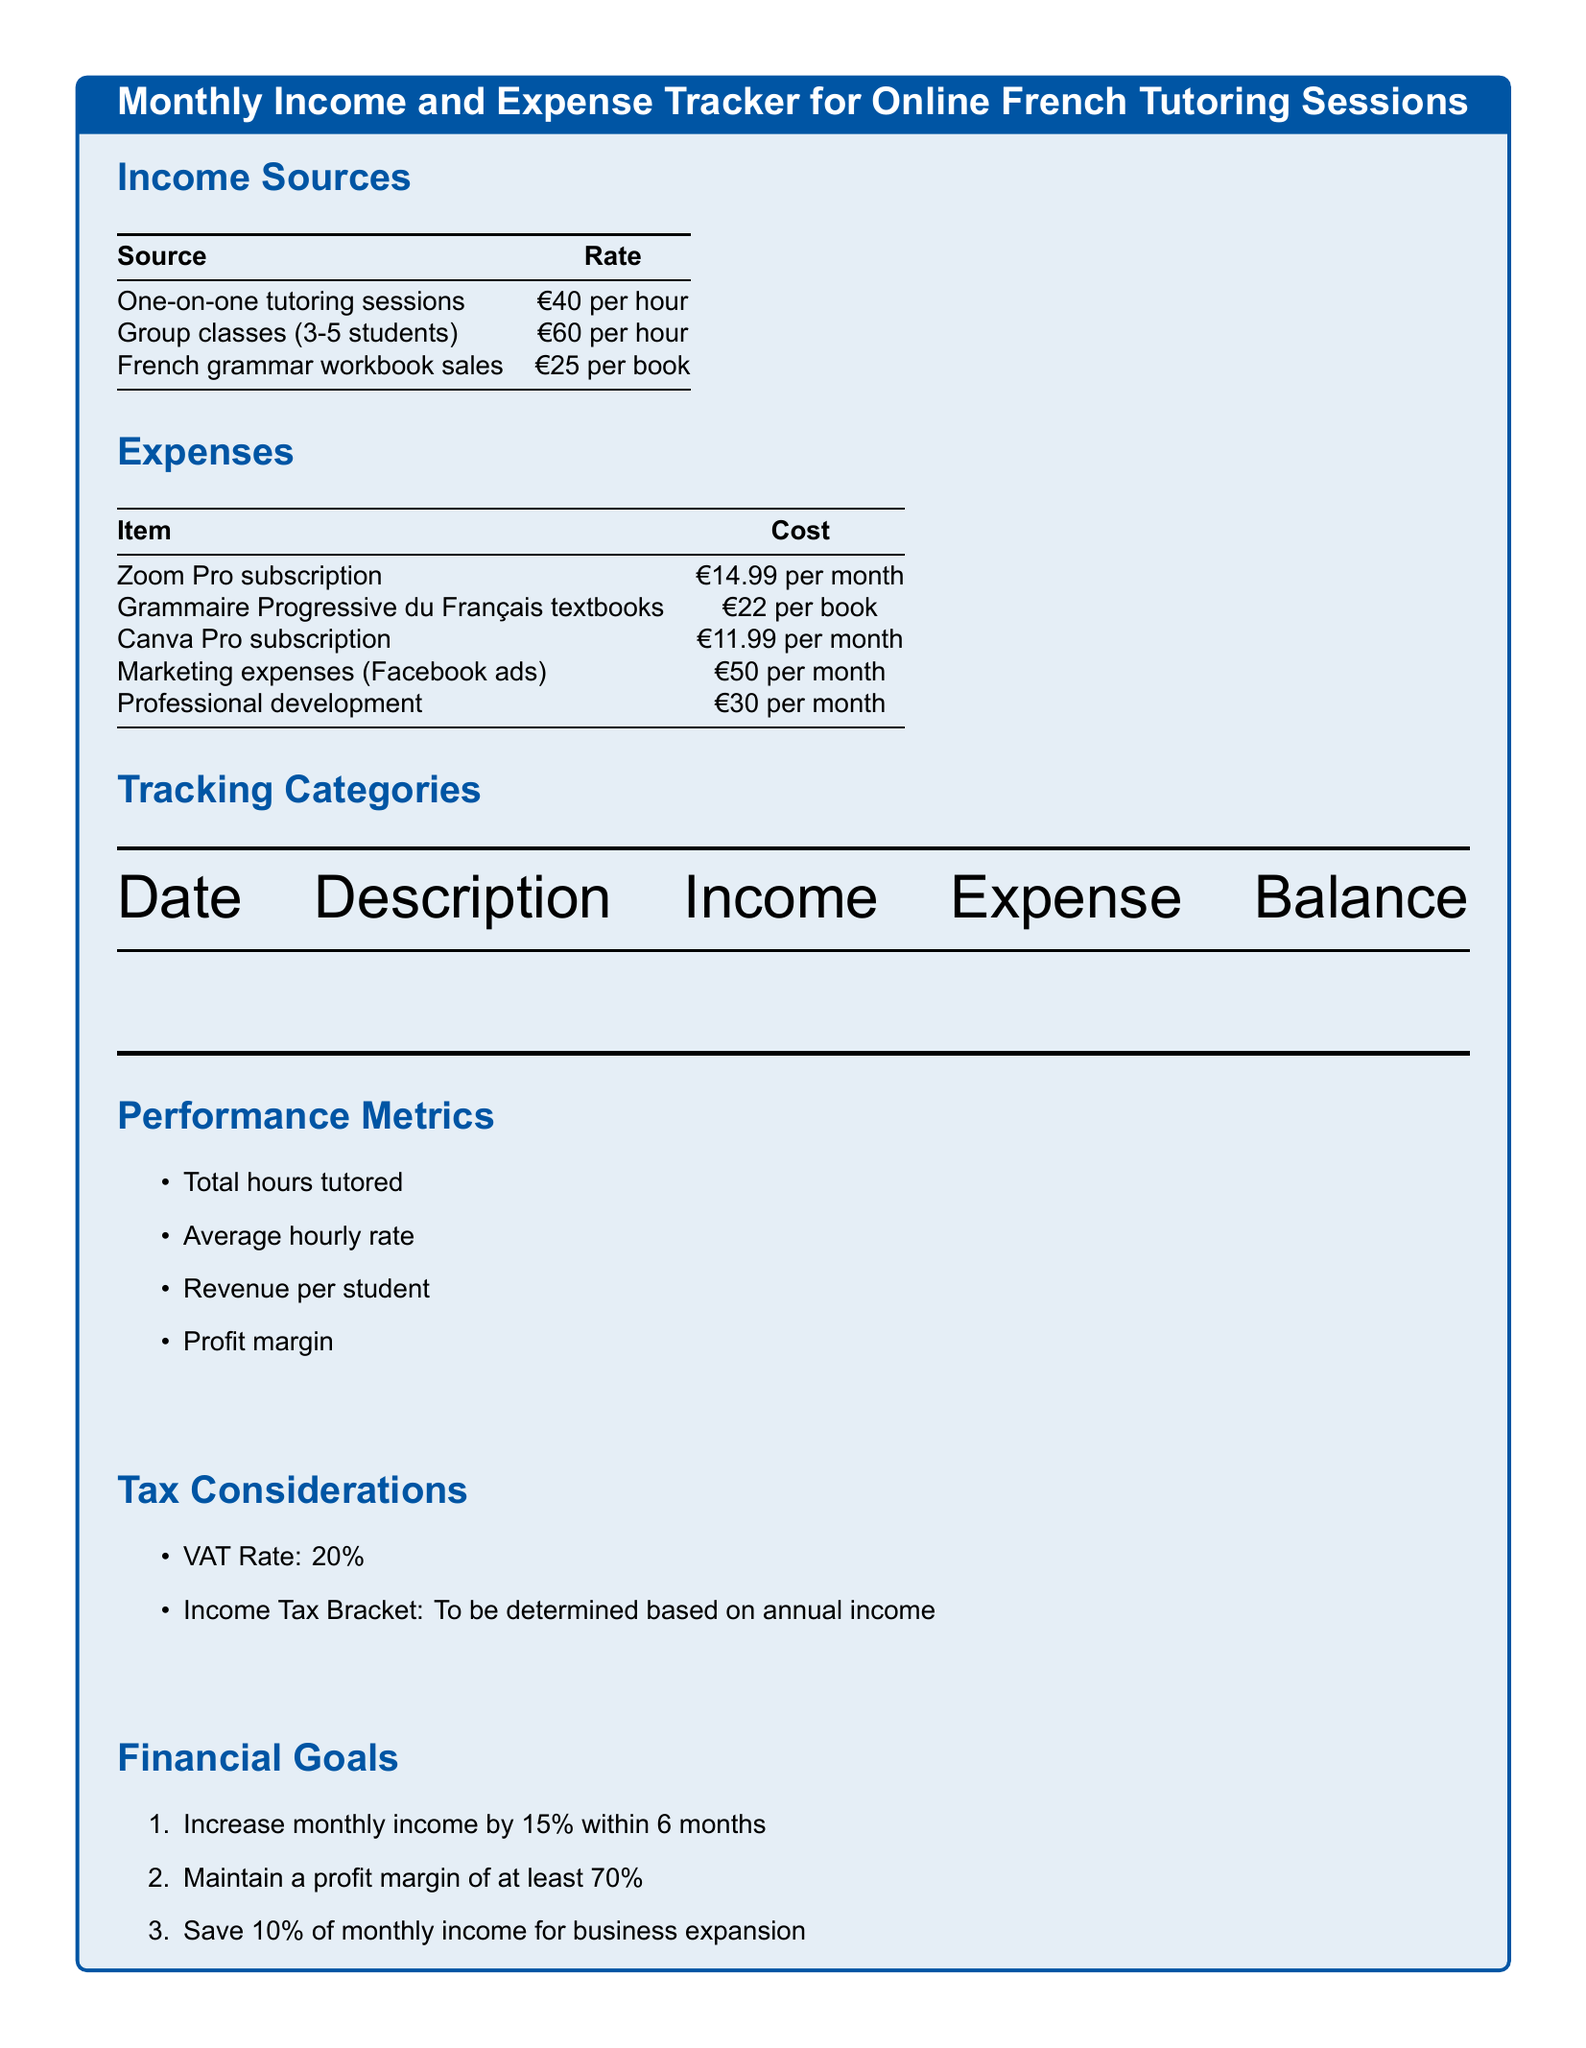What is the rate for one-on-one tutoring sessions? The document states that the rate for one-on-one tutoring sessions is €40 per hour.
Answer: €40 per hour What is the cost of a Zoom Pro subscription? According to the expenses section, the cost of a Zoom Pro subscription is €14.99 per month.
Answer: €14.99 per month What is the VAT rate mentioned? The document specifies that the VAT Rate is 20%.
Answer: 20% What percentage increase in monthly income is targeted? The financial goals outline that the target is to increase monthly income by 15% within 6 months.
Answer: 15% What is the cost of each French grammar workbook? The income sources section indicates that each French grammar workbook is €25.
Answer: €25 How much does the marketing expenses cost per month? The expenses list shows that marketing expenses for Facebook ads cost €50 per month.
Answer: €50 per month What is the average hourly rate? The performance metrics section mentions that average hourly rate is a key performance metric to track.
Answer: Average hourly rate What is the profit margin goal stated in the document? The financial goals section specifies that the goal is to maintain a profit margin of at least 70%.
Answer: 70% What is the cost of the Canva Pro subscription? The document states that the cost of the Canva Pro subscription is €11.99 per month.
Answer: €11.99 per month 